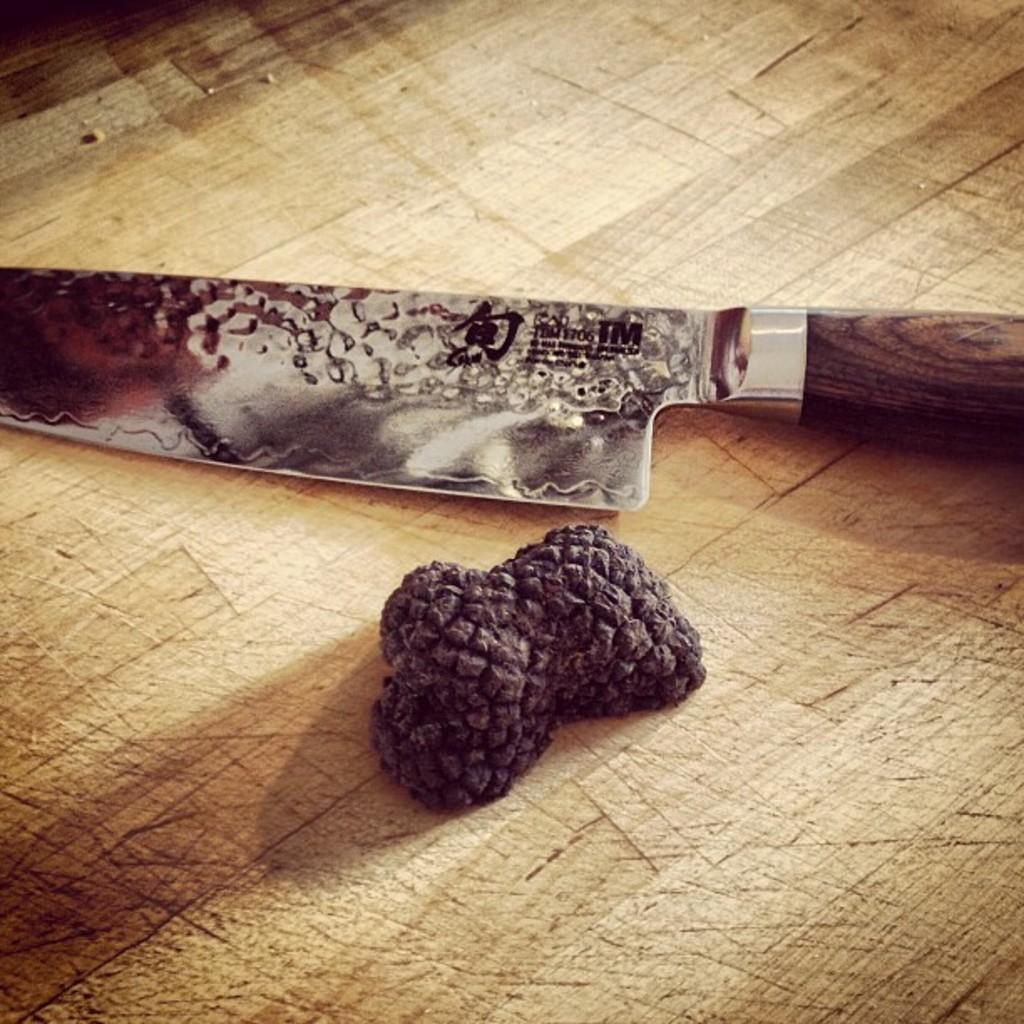What is the primary object visible in the image? There is a knife in the image. Can you describe the setting or context of the knife? The knife is placed on a wooden surface in the image. What type of zinc is being used to sharpen the knife in the image? There is no zinc present in the image, nor is there any indication that the knife is being sharpened. 